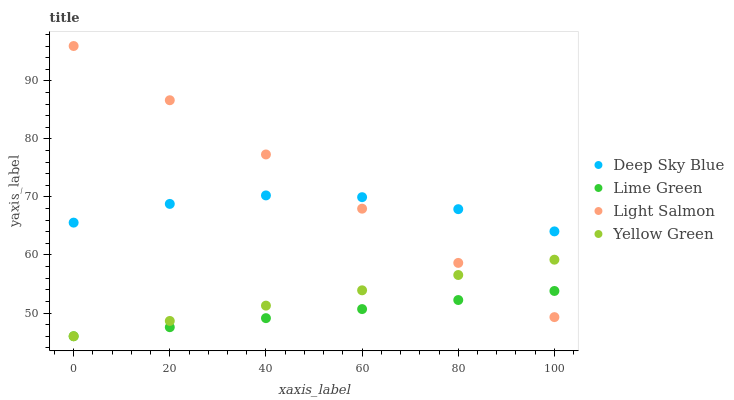Does Lime Green have the minimum area under the curve?
Answer yes or no. Yes. Does Light Salmon have the maximum area under the curve?
Answer yes or no. Yes. Does Yellow Green have the minimum area under the curve?
Answer yes or no. No. Does Yellow Green have the maximum area under the curve?
Answer yes or no. No. Is Yellow Green the smoothest?
Answer yes or no. Yes. Is Deep Sky Blue the roughest?
Answer yes or no. Yes. Is Lime Green the smoothest?
Answer yes or no. No. Is Lime Green the roughest?
Answer yes or no. No. Does Lime Green have the lowest value?
Answer yes or no. Yes. Does Deep Sky Blue have the lowest value?
Answer yes or no. No. Does Light Salmon have the highest value?
Answer yes or no. Yes. Does Yellow Green have the highest value?
Answer yes or no. No. Is Yellow Green less than Deep Sky Blue?
Answer yes or no. Yes. Is Deep Sky Blue greater than Yellow Green?
Answer yes or no. Yes. Does Yellow Green intersect Light Salmon?
Answer yes or no. Yes. Is Yellow Green less than Light Salmon?
Answer yes or no. No. Is Yellow Green greater than Light Salmon?
Answer yes or no. No. Does Yellow Green intersect Deep Sky Blue?
Answer yes or no. No. 